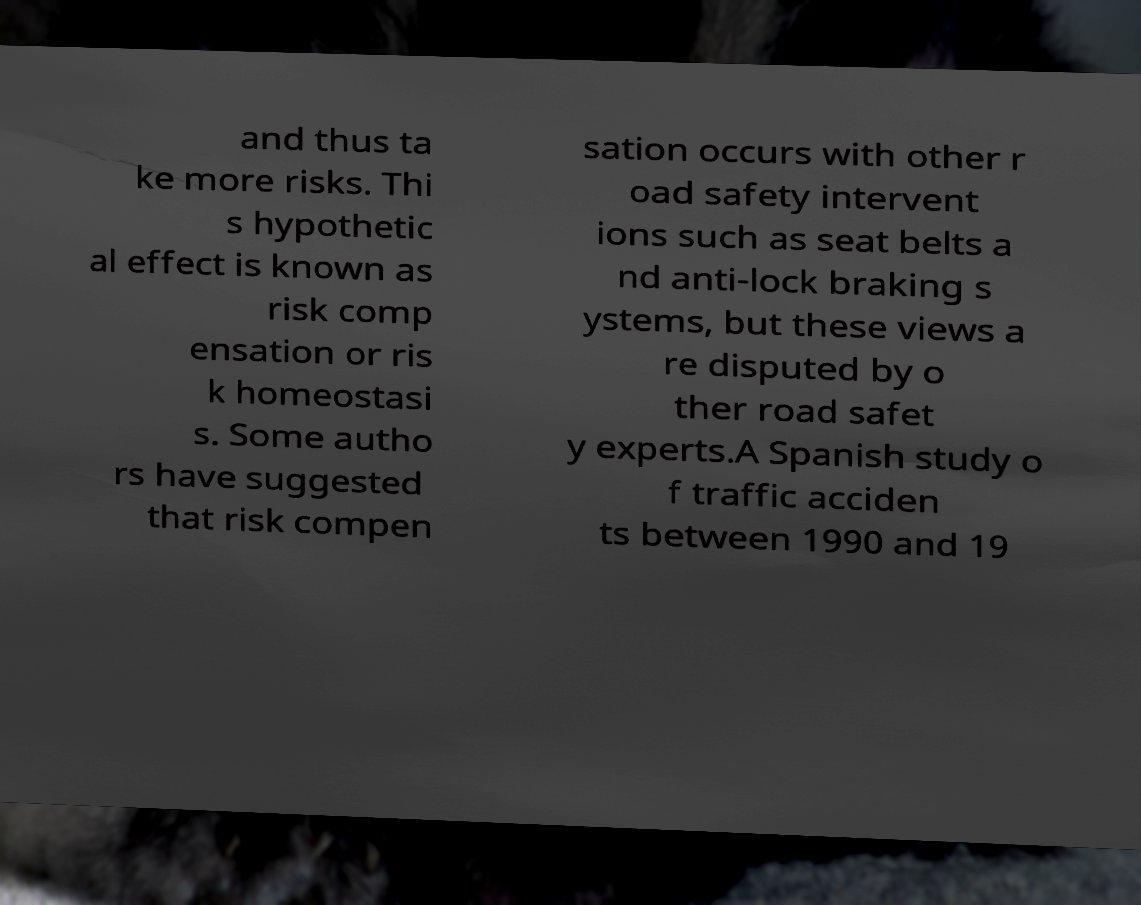Could you assist in decoding the text presented in this image and type it out clearly? and thus ta ke more risks. Thi s hypothetic al effect is known as risk comp ensation or ris k homeostasi s. Some autho rs have suggested that risk compen sation occurs with other r oad safety intervent ions such as seat belts a nd anti-lock braking s ystems, but these views a re disputed by o ther road safet y experts.A Spanish study o f traffic acciden ts between 1990 and 19 